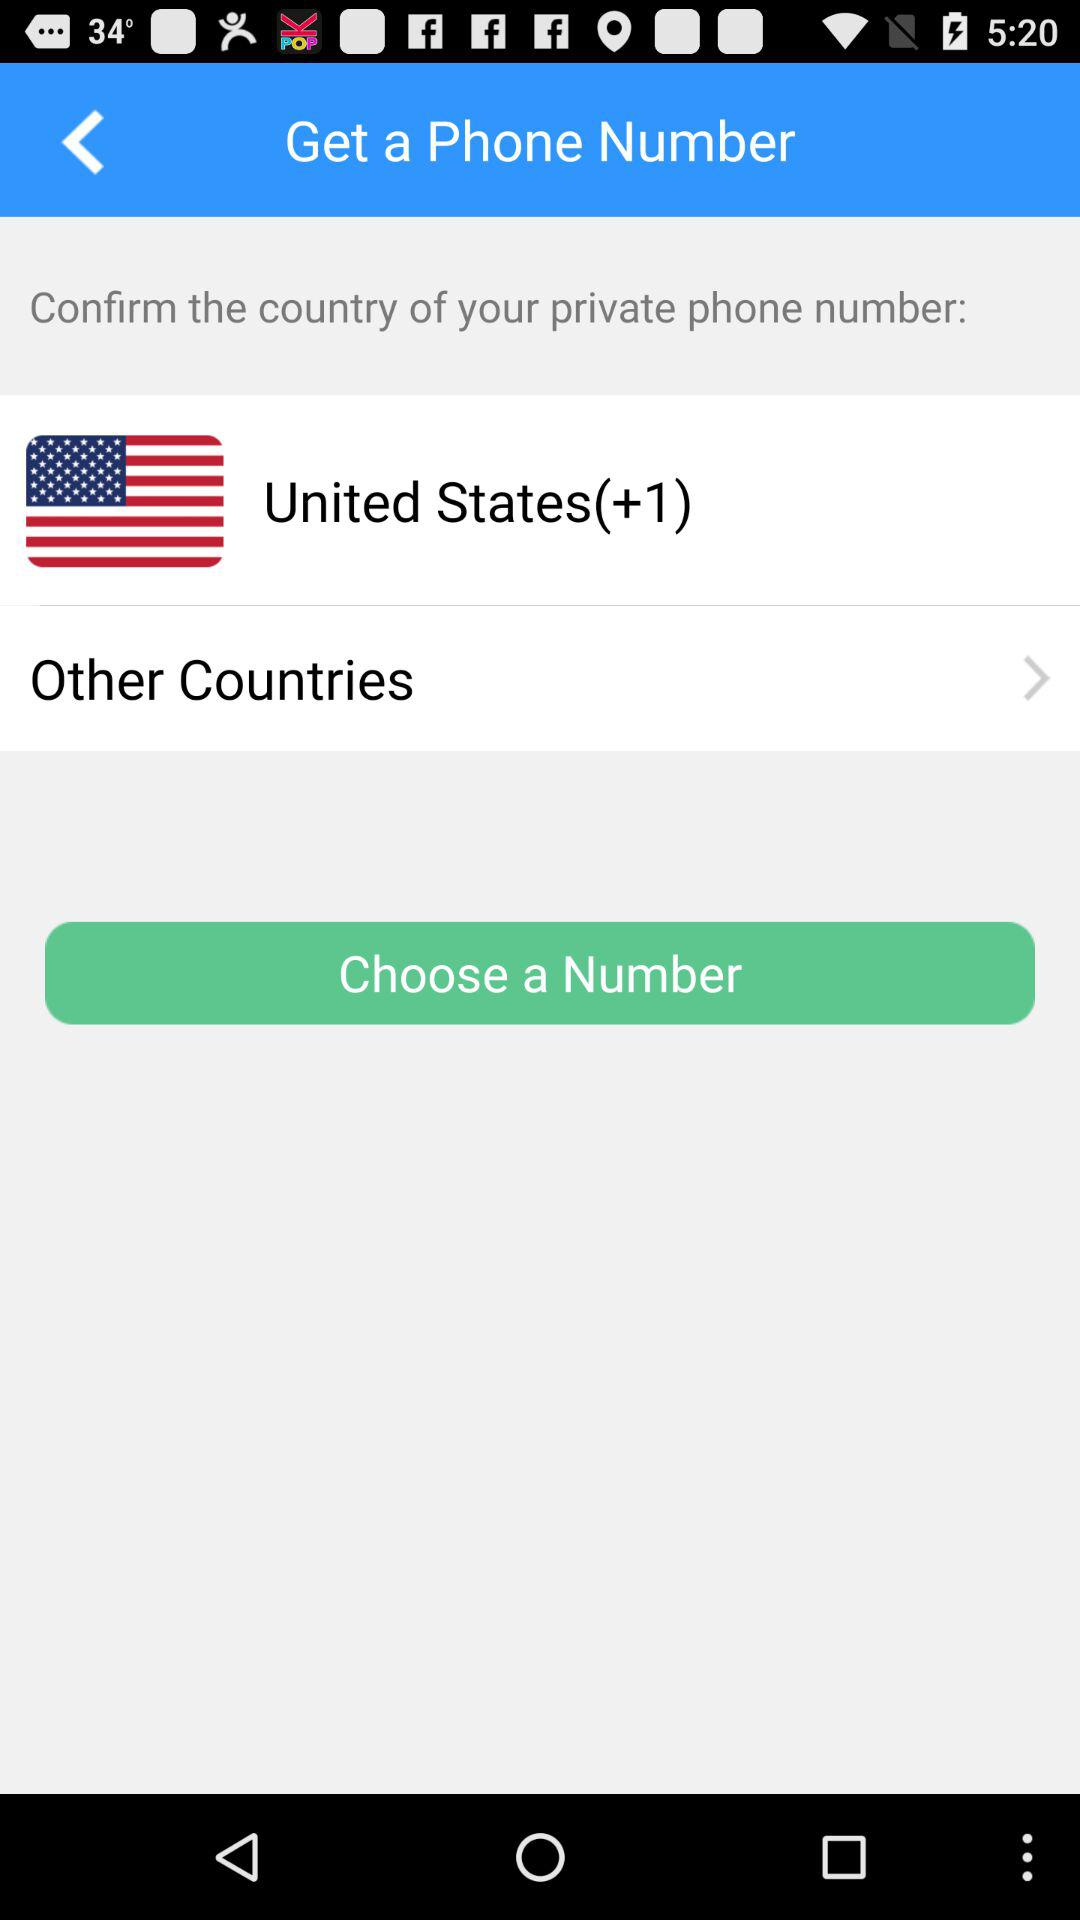How many other countries can be selected?
When the provided information is insufficient, respond with <no answer>. <no answer> 